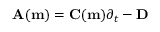Convert formula to latex. <formula><loc_0><loc_0><loc_500><loc_500>A ( m ) = C ( m ) \partial _ { t } - D</formula> 